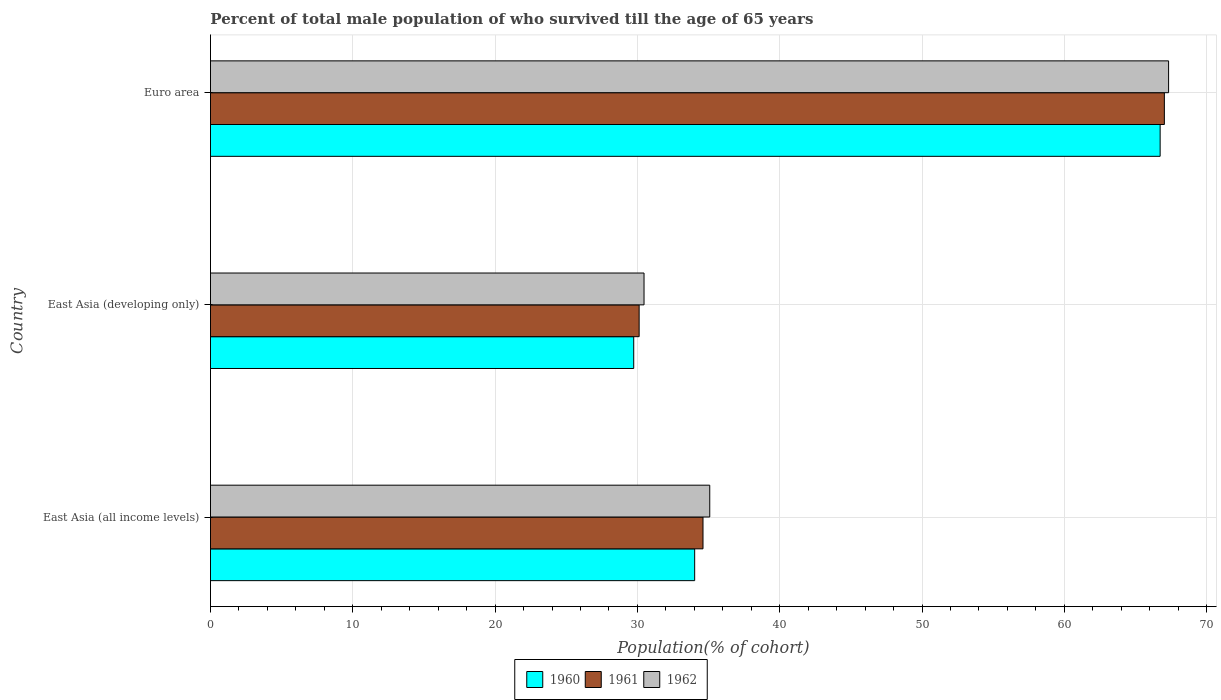How many different coloured bars are there?
Your answer should be very brief. 3. Are the number of bars on each tick of the Y-axis equal?
Offer a terse response. Yes. How many bars are there on the 1st tick from the top?
Make the answer very short. 3. What is the label of the 3rd group of bars from the top?
Make the answer very short. East Asia (all income levels). In how many cases, is the number of bars for a given country not equal to the number of legend labels?
Provide a short and direct response. 0. What is the percentage of total male population who survived till the age of 65 years in 1961 in Euro area?
Your answer should be very brief. 67.03. Across all countries, what is the maximum percentage of total male population who survived till the age of 65 years in 1960?
Keep it short and to the point. 66.73. Across all countries, what is the minimum percentage of total male population who survived till the age of 65 years in 1960?
Give a very brief answer. 29.74. In which country was the percentage of total male population who survived till the age of 65 years in 1960 minimum?
Offer a terse response. East Asia (developing only). What is the total percentage of total male population who survived till the age of 65 years in 1960 in the graph?
Keep it short and to the point. 130.49. What is the difference between the percentage of total male population who survived till the age of 65 years in 1960 in East Asia (all income levels) and that in Euro area?
Offer a terse response. -32.71. What is the difference between the percentage of total male population who survived till the age of 65 years in 1962 in East Asia (all income levels) and the percentage of total male population who survived till the age of 65 years in 1961 in East Asia (developing only)?
Your response must be concise. 4.96. What is the average percentage of total male population who survived till the age of 65 years in 1961 per country?
Your answer should be very brief. 43.92. What is the difference between the percentage of total male population who survived till the age of 65 years in 1960 and percentage of total male population who survived till the age of 65 years in 1962 in Euro area?
Your answer should be very brief. -0.59. What is the ratio of the percentage of total male population who survived till the age of 65 years in 1962 in East Asia (developing only) to that in Euro area?
Offer a very short reply. 0.45. What is the difference between the highest and the second highest percentage of total male population who survived till the age of 65 years in 1960?
Provide a short and direct response. 32.71. What is the difference between the highest and the lowest percentage of total male population who survived till the age of 65 years in 1961?
Ensure brevity in your answer.  36.9. Is the sum of the percentage of total male population who survived till the age of 65 years in 1961 in East Asia (developing only) and Euro area greater than the maximum percentage of total male population who survived till the age of 65 years in 1962 across all countries?
Offer a terse response. Yes. What does the 2nd bar from the top in Euro area represents?
Offer a terse response. 1961. What does the 1st bar from the bottom in East Asia (developing only) represents?
Your answer should be very brief. 1960. How many bars are there?
Make the answer very short. 9. How many countries are there in the graph?
Keep it short and to the point. 3. What is the difference between two consecutive major ticks on the X-axis?
Offer a very short reply. 10. Are the values on the major ticks of X-axis written in scientific E-notation?
Your answer should be compact. No. How many legend labels are there?
Offer a terse response. 3. What is the title of the graph?
Keep it short and to the point. Percent of total male population of who survived till the age of 65 years. What is the label or title of the X-axis?
Offer a terse response. Population(% of cohort). What is the label or title of the Y-axis?
Give a very brief answer. Country. What is the Population(% of cohort) of 1960 in East Asia (all income levels)?
Your answer should be very brief. 34.02. What is the Population(% of cohort) in 1961 in East Asia (all income levels)?
Make the answer very short. 34.61. What is the Population(% of cohort) of 1962 in East Asia (all income levels)?
Keep it short and to the point. 35.08. What is the Population(% of cohort) of 1960 in East Asia (developing only)?
Your answer should be compact. 29.74. What is the Population(% of cohort) in 1961 in East Asia (developing only)?
Offer a very short reply. 30.12. What is the Population(% of cohort) of 1962 in East Asia (developing only)?
Your answer should be compact. 30.46. What is the Population(% of cohort) of 1960 in Euro area?
Make the answer very short. 66.73. What is the Population(% of cohort) in 1961 in Euro area?
Ensure brevity in your answer.  67.03. What is the Population(% of cohort) of 1962 in Euro area?
Offer a very short reply. 67.32. Across all countries, what is the maximum Population(% of cohort) in 1960?
Offer a very short reply. 66.73. Across all countries, what is the maximum Population(% of cohort) of 1961?
Make the answer very short. 67.03. Across all countries, what is the maximum Population(% of cohort) in 1962?
Your answer should be compact. 67.32. Across all countries, what is the minimum Population(% of cohort) in 1960?
Provide a succinct answer. 29.74. Across all countries, what is the minimum Population(% of cohort) of 1961?
Provide a short and direct response. 30.12. Across all countries, what is the minimum Population(% of cohort) in 1962?
Your response must be concise. 30.46. What is the total Population(% of cohort) in 1960 in the graph?
Give a very brief answer. 130.49. What is the total Population(% of cohort) in 1961 in the graph?
Ensure brevity in your answer.  131.75. What is the total Population(% of cohort) of 1962 in the graph?
Provide a succinct answer. 132.87. What is the difference between the Population(% of cohort) of 1960 in East Asia (all income levels) and that in East Asia (developing only)?
Give a very brief answer. 4.28. What is the difference between the Population(% of cohort) of 1961 in East Asia (all income levels) and that in East Asia (developing only)?
Provide a short and direct response. 4.49. What is the difference between the Population(% of cohort) of 1962 in East Asia (all income levels) and that in East Asia (developing only)?
Your response must be concise. 4.62. What is the difference between the Population(% of cohort) in 1960 in East Asia (all income levels) and that in Euro area?
Your response must be concise. -32.71. What is the difference between the Population(% of cohort) in 1961 in East Asia (all income levels) and that in Euro area?
Your response must be concise. -32.42. What is the difference between the Population(% of cohort) of 1962 in East Asia (all income levels) and that in Euro area?
Offer a terse response. -32.24. What is the difference between the Population(% of cohort) of 1960 in East Asia (developing only) and that in Euro area?
Your response must be concise. -36.99. What is the difference between the Population(% of cohort) in 1961 in East Asia (developing only) and that in Euro area?
Keep it short and to the point. -36.9. What is the difference between the Population(% of cohort) of 1962 in East Asia (developing only) and that in Euro area?
Offer a terse response. -36.86. What is the difference between the Population(% of cohort) of 1960 in East Asia (all income levels) and the Population(% of cohort) of 1961 in East Asia (developing only)?
Make the answer very short. 3.9. What is the difference between the Population(% of cohort) in 1960 in East Asia (all income levels) and the Population(% of cohort) in 1962 in East Asia (developing only)?
Offer a terse response. 3.56. What is the difference between the Population(% of cohort) of 1961 in East Asia (all income levels) and the Population(% of cohort) of 1962 in East Asia (developing only)?
Keep it short and to the point. 4.14. What is the difference between the Population(% of cohort) in 1960 in East Asia (all income levels) and the Population(% of cohort) in 1961 in Euro area?
Make the answer very short. -33. What is the difference between the Population(% of cohort) of 1960 in East Asia (all income levels) and the Population(% of cohort) of 1962 in Euro area?
Give a very brief answer. -33.3. What is the difference between the Population(% of cohort) of 1961 in East Asia (all income levels) and the Population(% of cohort) of 1962 in Euro area?
Give a very brief answer. -32.71. What is the difference between the Population(% of cohort) in 1960 in East Asia (developing only) and the Population(% of cohort) in 1961 in Euro area?
Provide a short and direct response. -37.29. What is the difference between the Population(% of cohort) of 1960 in East Asia (developing only) and the Population(% of cohort) of 1962 in Euro area?
Your answer should be very brief. -37.58. What is the difference between the Population(% of cohort) of 1961 in East Asia (developing only) and the Population(% of cohort) of 1962 in Euro area?
Keep it short and to the point. -37.2. What is the average Population(% of cohort) in 1960 per country?
Offer a very short reply. 43.5. What is the average Population(% of cohort) in 1961 per country?
Offer a very short reply. 43.92. What is the average Population(% of cohort) of 1962 per country?
Your answer should be compact. 44.29. What is the difference between the Population(% of cohort) of 1960 and Population(% of cohort) of 1961 in East Asia (all income levels)?
Provide a succinct answer. -0.59. What is the difference between the Population(% of cohort) of 1960 and Population(% of cohort) of 1962 in East Asia (all income levels)?
Ensure brevity in your answer.  -1.06. What is the difference between the Population(% of cohort) of 1961 and Population(% of cohort) of 1962 in East Asia (all income levels)?
Give a very brief answer. -0.47. What is the difference between the Population(% of cohort) in 1960 and Population(% of cohort) in 1961 in East Asia (developing only)?
Keep it short and to the point. -0.38. What is the difference between the Population(% of cohort) in 1960 and Population(% of cohort) in 1962 in East Asia (developing only)?
Your response must be concise. -0.73. What is the difference between the Population(% of cohort) of 1961 and Population(% of cohort) of 1962 in East Asia (developing only)?
Your answer should be compact. -0.34. What is the difference between the Population(% of cohort) of 1960 and Population(% of cohort) of 1961 in Euro area?
Make the answer very short. -0.3. What is the difference between the Population(% of cohort) of 1960 and Population(% of cohort) of 1962 in Euro area?
Provide a short and direct response. -0.59. What is the difference between the Population(% of cohort) in 1961 and Population(% of cohort) in 1962 in Euro area?
Provide a succinct answer. -0.3. What is the ratio of the Population(% of cohort) of 1960 in East Asia (all income levels) to that in East Asia (developing only)?
Provide a short and direct response. 1.14. What is the ratio of the Population(% of cohort) of 1961 in East Asia (all income levels) to that in East Asia (developing only)?
Your response must be concise. 1.15. What is the ratio of the Population(% of cohort) in 1962 in East Asia (all income levels) to that in East Asia (developing only)?
Keep it short and to the point. 1.15. What is the ratio of the Population(% of cohort) in 1960 in East Asia (all income levels) to that in Euro area?
Provide a short and direct response. 0.51. What is the ratio of the Population(% of cohort) of 1961 in East Asia (all income levels) to that in Euro area?
Ensure brevity in your answer.  0.52. What is the ratio of the Population(% of cohort) of 1962 in East Asia (all income levels) to that in Euro area?
Provide a short and direct response. 0.52. What is the ratio of the Population(% of cohort) of 1960 in East Asia (developing only) to that in Euro area?
Provide a short and direct response. 0.45. What is the ratio of the Population(% of cohort) of 1961 in East Asia (developing only) to that in Euro area?
Provide a short and direct response. 0.45. What is the ratio of the Population(% of cohort) in 1962 in East Asia (developing only) to that in Euro area?
Keep it short and to the point. 0.45. What is the difference between the highest and the second highest Population(% of cohort) in 1960?
Your answer should be compact. 32.71. What is the difference between the highest and the second highest Population(% of cohort) in 1961?
Offer a very short reply. 32.42. What is the difference between the highest and the second highest Population(% of cohort) in 1962?
Keep it short and to the point. 32.24. What is the difference between the highest and the lowest Population(% of cohort) in 1960?
Your response must be concise. 36.99. What is the difference between the highest and the lowest Population(% of cohort) of 1961?
Keep it short and to the point. 36.9. What is the difference between the highest and the lowest Population(% of cohort) in 1962?
Ensure brevity in your answer.  36.86. 